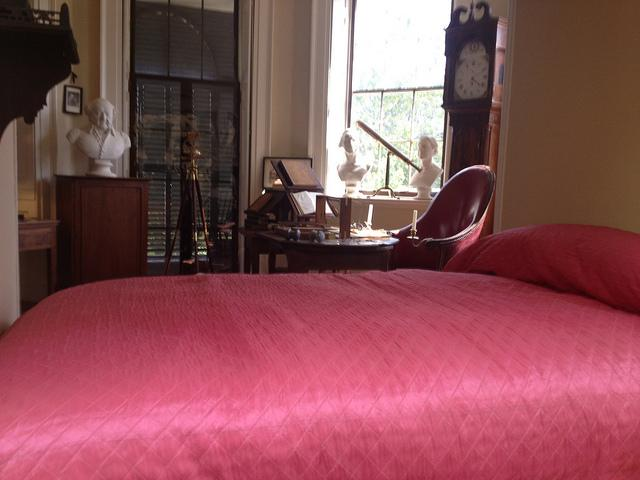What category of clocks does the clock by the window belong to? grandfather 